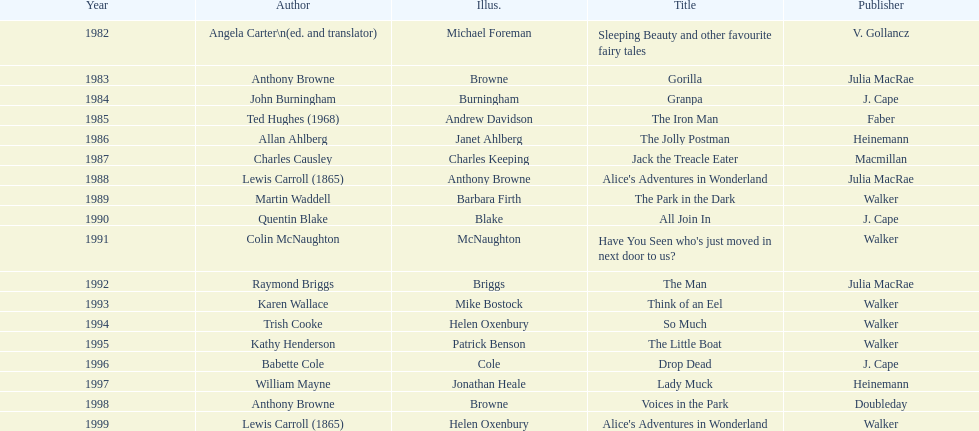How many times has anthony browne won an kurt maschler award for illustration? 3. 